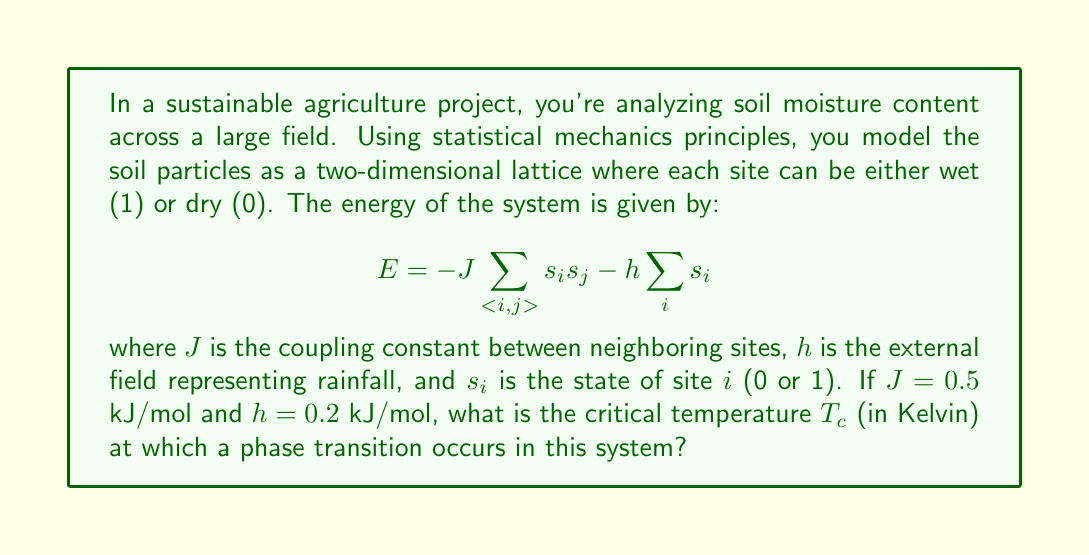Can you solve this math problem? To solve this problem, we'll use the principles of statistical mechanics and the Ising model, which is analogous to our soil moisture system. The steps are as follows:

1) In a 2D Ising model, the critical temperature is given by the Onsager solution:

   $$\frac{k_B T_c}{J} = \frac{2}{\ln(1+\sqrt{2})} \approx 2.269$$

   where $k_B$ is the Boltzmann constant.

2) We need to rearrange this equation to solve for $T_c$:

   $$T_c = \frac{2J}{k_B \ln(1+\sqrt{2})}$$

3) We're given $J = 0.5$ kJ/mol. We need to convert this to J/molecule:

   $$J = 0.5 \frac{\text{kJ}}{\text{mol}} \times \frac{1000 \text{ J}}{1 \text{ kJ}} \times \frac{1 \text{ mol}}{6.022 \times 10^{23} \text{ molecules}} = 8.303 \times 10^{-22} \text{ J/molecule}$$

4) The Boltzmann constant is $k_B = 1.380649 \times 10^{-23}$ J/K.

5) Now we can substitute these values into our equation:

   $$T_c = \frac{2(8.303 \times 10^{-22})}{(1.380649 \times 10^{-23}) \ln(1+\sqrt{2})} \approx 85.7 \text{ K}$$

6) Note that the external field $h$ doesn't directly affect the critical temperature in this simple model, but it would influence the overall behavior of the system.
Answer: 85.7 K 